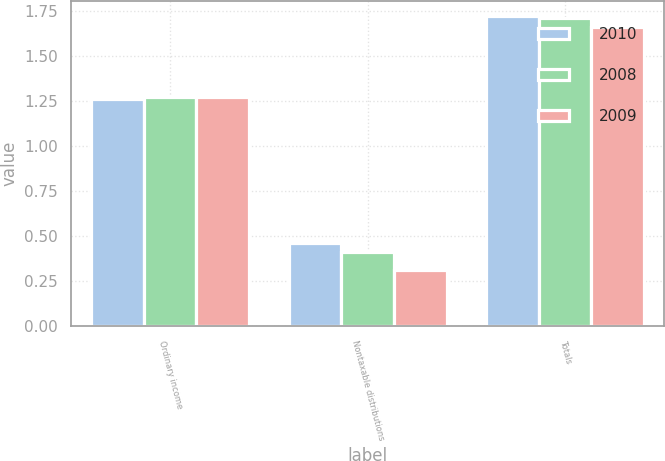<chart> <loc_0><loc_0><loc_500><loc_500><stacked_bar_chart><ecel><fcel>Ordinary income<fcel>Nontaxable distributions<fcel>Totals<nl><fcel>2010<fcel>1.26<fcel>0.46<fcel>1.72<nl><fcel>2008<fcel>1.27<fcel>0.41<fcel>1.71<nl><fcel>2009<fcel>1.27<fcel>0.31<fcel>1.66<nl></chart> 